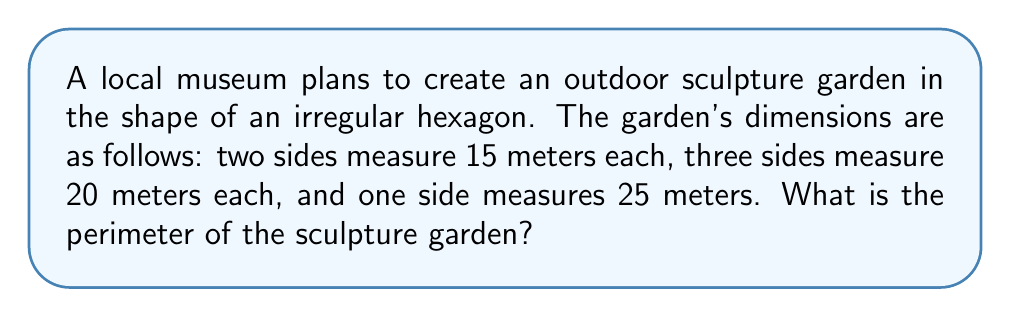Could you help me with this problem? To calculate the perimeter of the hexagonal sculpture garden, we need to sum up the lengths of all sides. Let's break it down step by step:

1. Identify the given information:
   - Two sides measure 15 meters each
   - Three sides measure 20 meters each
   - One side measures 25 meters

2. Calculate the total length of the 15-meter sides:
   $15 \text{ m} \times 2 = 30 \text{ m}$

3. Calculate the total length of the 20-meter sides:
   $20 \text{ m} \times 3 = 60 \text{ m}$

4. The 25-meter side remains as is.

5. Sum up all the sides to get the perimeter:
   $$\text{Perimeter} = 30 \text{ m} + 60 \text{ m} + 25 \text{ m} = 115 \text{ m}$$

Therefore, the perimeter of the hexagonal sculpture garden is 115 meters.
Answer: 115 m 